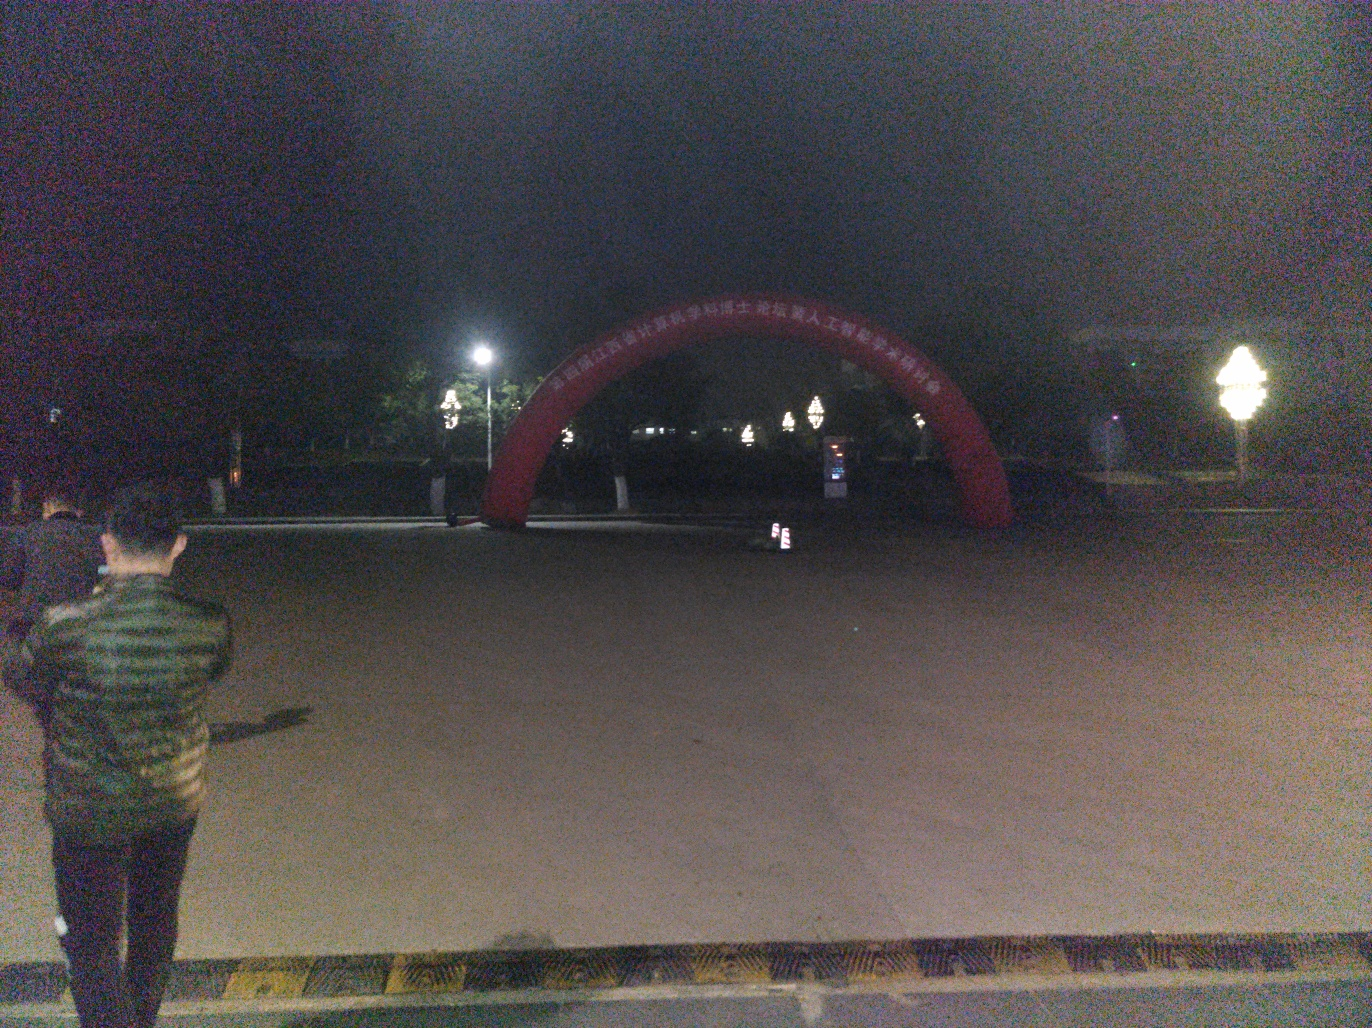How can the photo be improved to capture the scene better? To improve the photo, one could use a tripod to stabilize the camera for a longer exposure, allowing more light in. Additionally, manually adjusting the ISO settings, aperture, and exposure compensation would help to brighten the image and reveal more details. If the camera has a 'Night Mode,' that setting could be particularly beneficial here. 